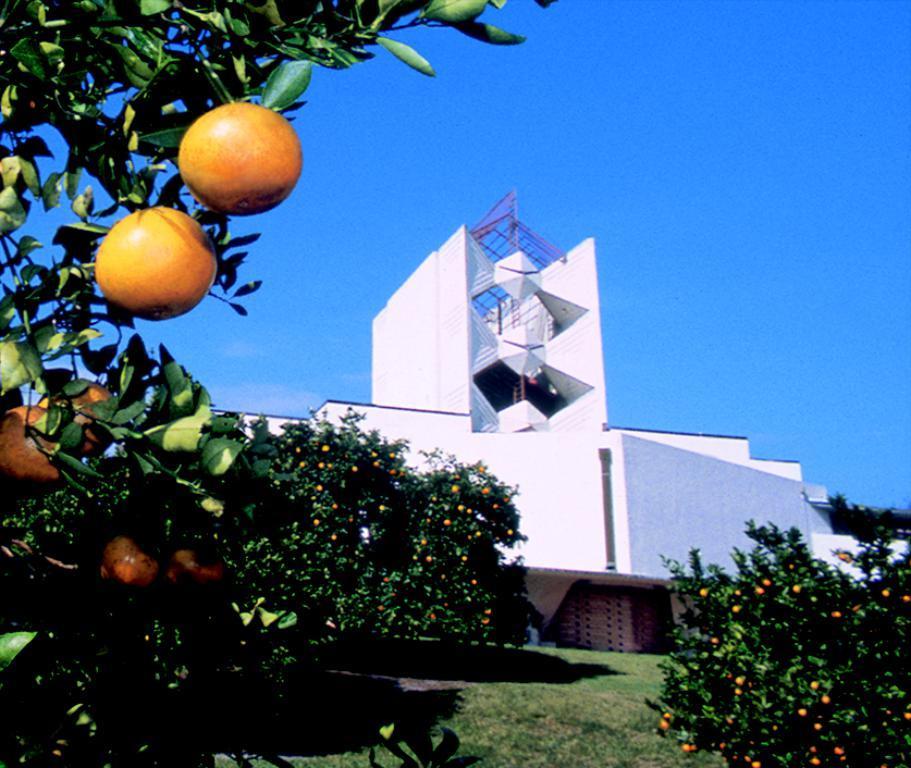Could you give a brief overview of what you see in this image? In this image we can see sky, buildings, trees with fruits and ground. 